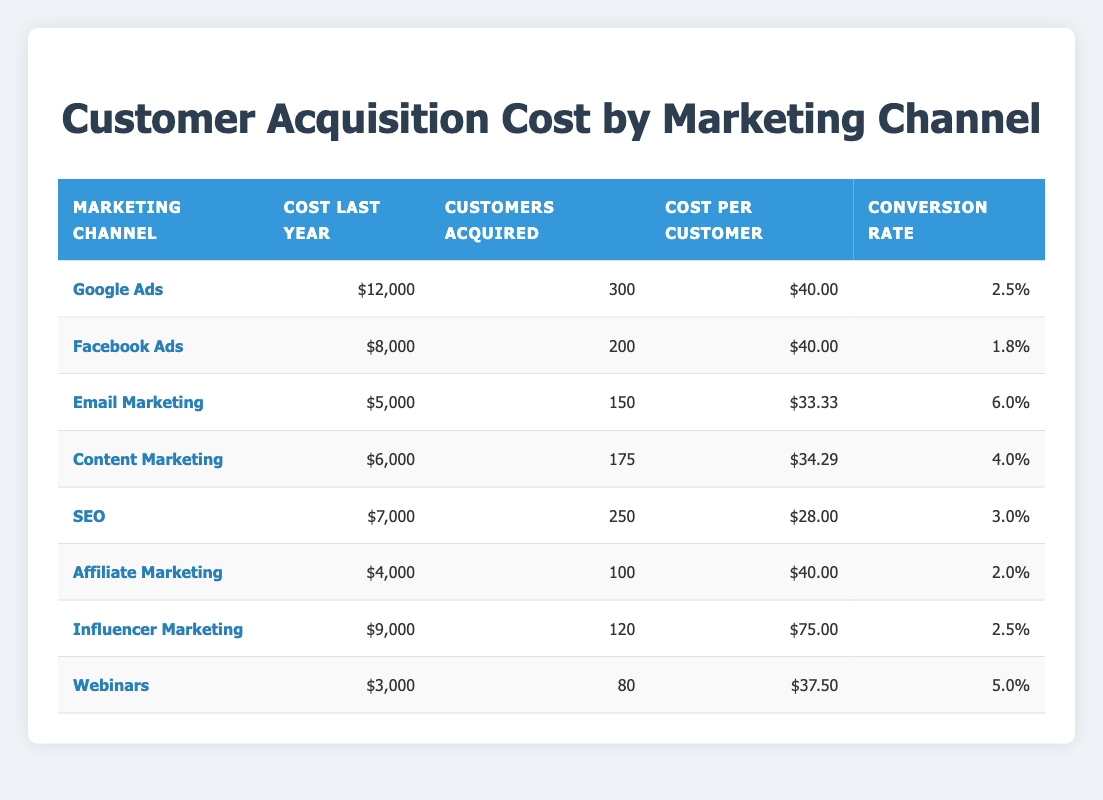What is the total customer acquisition cost for Google Ads? The cost last year for Google Ads is listed as 12,000. This is a direct retrieval from the table.
Answer: 12,000 How many customers were acquired through Facebook Ads? The table shows that Facebook Ads acquired 200 customers last year, which is a direct retrieval from the table.
Answer: 200 What is the conversion rate for Email Marketing? The conversion rate for Email Marketing is stated as 6.0% in the table, a simple retrieval.
Answer: 6.0 Which marketing channel had the highest cost per customer? The cost per customer for Influencer Marketing is 75.00, which is higher than all other channels when checked against their respective costs per customer.
Answer: Influencer Marketing What is the average cost per customer across all channels? The costs per customer are: 40, 40, 33.33, 34.29, 28, 40, 75, and 37.50. The total cost per customer is (40 + 40 + 33.33 + 34.29 + 28 + 40 + 75 + 37.50) = 318.12. There are 8 channels, so the average is 318.12 / 8 = 39.76.
Answer: 39.76 Did SEO have a better conversion rate than Facebook Ads? SEO had a conversion rate of 3.0%, while Facebook Ads had a conversion rate of 1.8%. Comparing these two values reveals that SEO did indeed have a better conversion rate.
Answer: Yes What was the total cost associated with acquiring customers through Content Marketing and Webinars? The cost for Content Marketing is 6,000, while for Webinars, it is 3,000. Summing these gives 6,000 + 3,000 = 9,000 for both channels combined.
Answer: 9,000 Which marketing channel had the lowest total cost last year? The table shows that Affiliate Marketing had a cost of 4,000, which is lower than all other channels when compared.
Answer: Affiliate Marketing How many customers were acquired through Email Marketing compared to Influencer Marketing? Email Marketing acquired 150 customers while Influencer Marketing acquired 120 customers. Comparing these directly shows Email Marketing acquired more customers.
Answer: Email Marketing had more customers What is the difference in conversion rates between the highest and lowest marketing channels? The conversion rate for Email Marketing is 6.0% (highest) and for Affiliate Marketing is 2.0% (lowest). The difference is 6.0 - 2.0 = 4.0%.
Answer: 4.0 